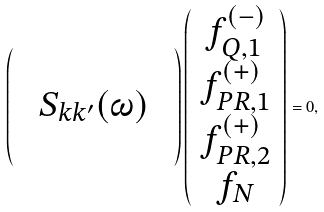<formula> <loc_0><loc_0><loc_500><loc_500>\left ( \begin{array} { c c c } & & \\ & S _ { k k ^ { \prime } } ( \omega ) & \\ & & \\ \end{array} \right ) \left ( \begin{array} { c } f ^ { ( - ) } _ { Q , 1 } \\ f ^ { ( + ) } _ { P R , 1 } \\ f ^ { ( + ) } _ { P R , 2 } \\ f _ { N } \\ \end{array} \right ) = 0 ,</formula> 